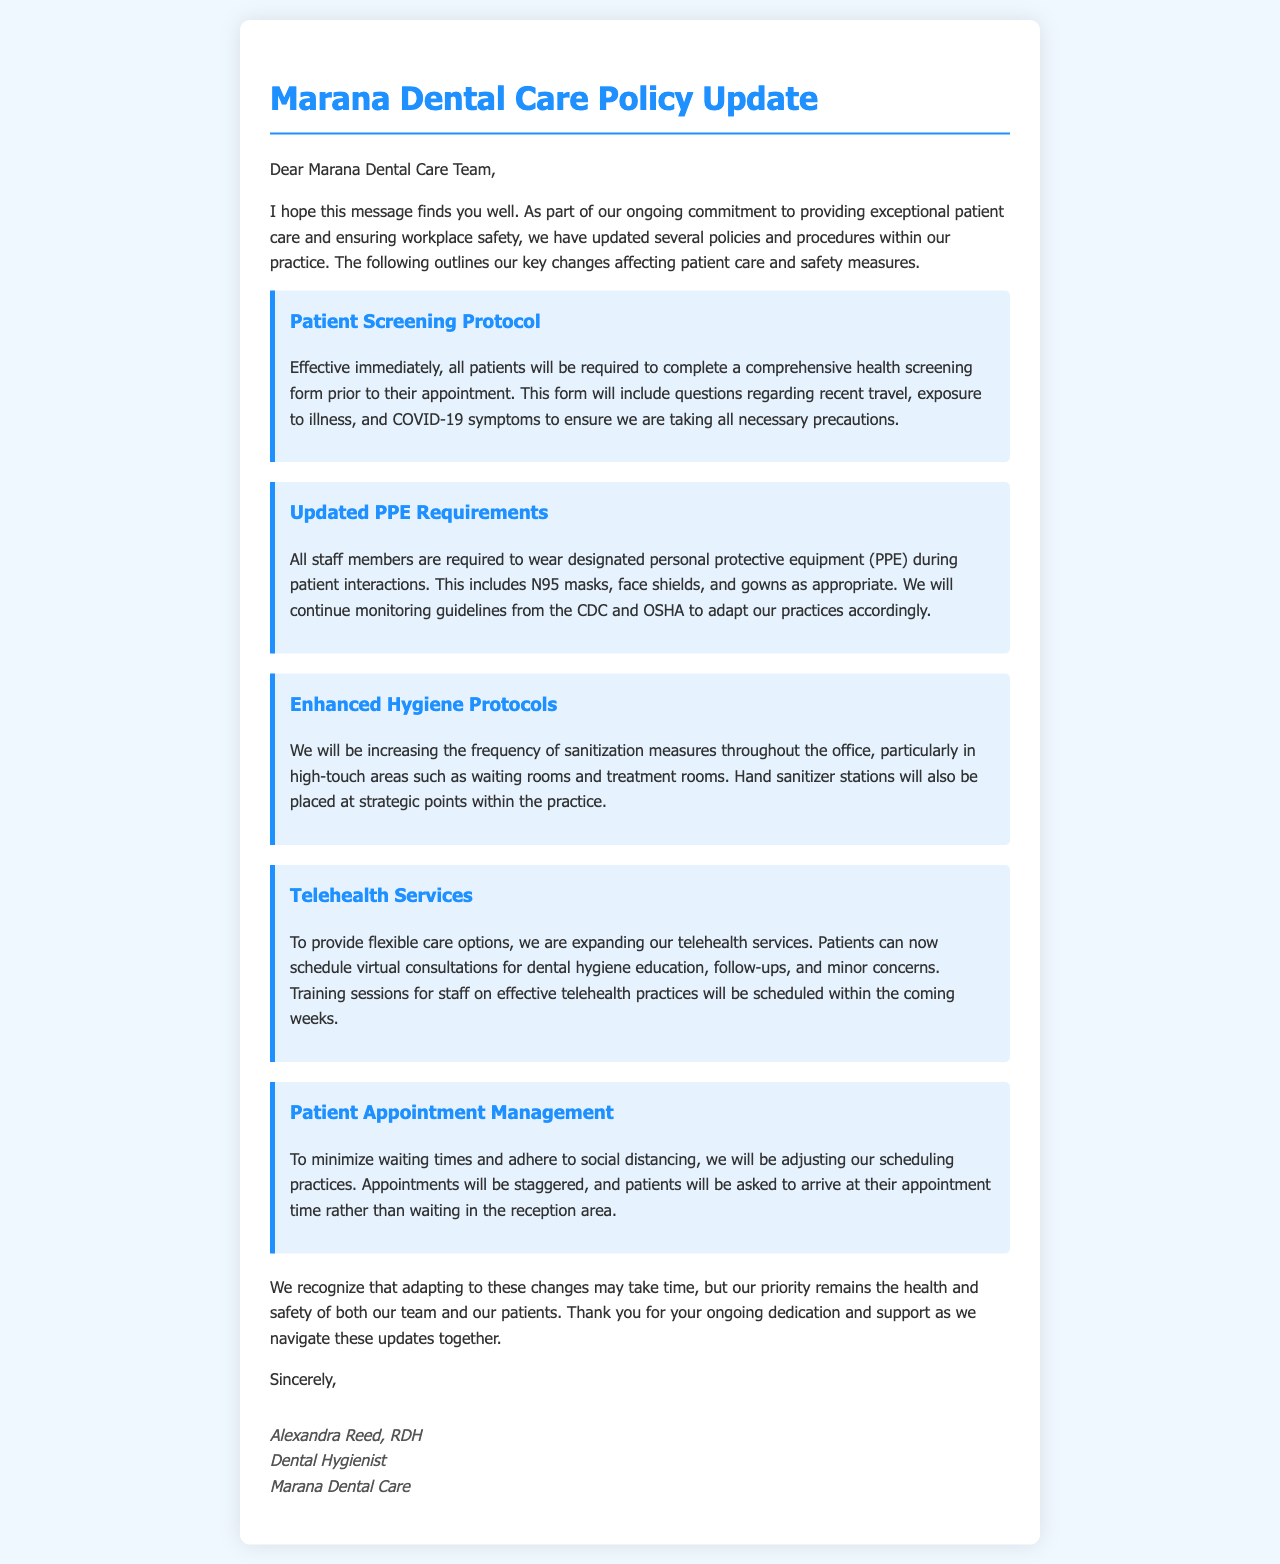What is the new patient screening requirement? All patients will be required to complete a comprehensive health screening form prior to their appointment.
Answer: Comprehensive health screening form What type of PPE is required for staff? Staff members are required to wear designated personal protective equipment, including N95 masks, face shields, and gowns.
Answer: N95 masks, face shields, and gowns How often will sanitization measures be increased? The document states we will be increasing the frequency of sanitization measures throughout the office.
Answer: Increased frequency What new service is being expanded? The practice is expanding telehealth services for flexible care options.
Answer: Telehealth services How will patient appointment scheduling be adjusted? Appointments will be staggered, and patients will be asked to arrive at their appointment time.
Answer: Staggered appointments Who signed the letter? The letter is signed by Alexandra Reed, RDH, Dental Hygienist.
Answer: Alexandra Reed, RDH What is the main priority mentioned in the letter? The main priority mentioned is the health and safety of both our team and our patients.
Answer: Health and safety When will training sessions for telehealth practices be scheduled? The letter states training sessions will be scheduled within the coming weeks.
Answer: Within the coming weeks 